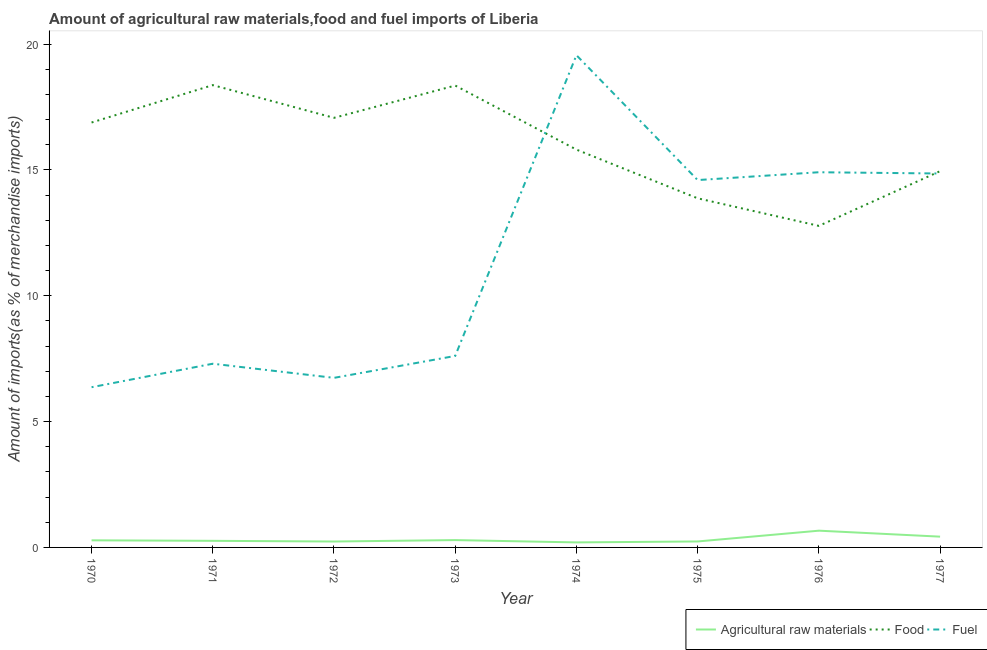Is the number of lines equal to the number of legend labels?
Provide a succinct answer. Yes. What is the percentage of raw materials imports in 1971?
Offer a very short reply. 0.26. Across all years, what is the maximum percentage of fuel imports?
Provide a succinct answer. 19.56. Across all years, what is the minimum percentage of food imports?
Provide a succinct answer. 12.78. In which year was the percentage of raw materials imports maximum?
Give a very brief answer. 1976. What is the total percentage of fuel imports in the graph?
Your answer should be very brief. 91.93. What is the difference between the percentage of raw materials imports in 1974 and that in 1976?
Offer a very short reply. -0.47. What is the difference between the percentage of food imports in 1975 and the percentage of raw materials imports in 1970?
Ensure brevity in your answer.  13.59. What is the average percentage of fuel imports per year?
Give a very brief answer. 11.49. In the year 1974, what is the difference between the percentage of fuel imports and percentage of food imports?
Give a very brief answer. 3.75. In how many years, is the percentage of raw materials imports greater than 4 %?
Keep it short and to the point. 0. What is the ratio of the percentage of food imports in 1970 to that in 1977?
Offer a terse response. 1.13. What is the difference between the highest and the second highest percentage of food imports?
Provide a short and direct response. 0.02. What is the difference between the highest and the lowest percentage of food imports?
Keep it short and to the point. 5.59. Is the sum of the percentage of fuel imports in 1974 and 1975 greater than the maximum percentage of raw materials imports across all years?
Your answer should be very brief. Yes. Is it the case that in every year, the sum of the percentage of raw materials imports and percentage of food imports is greater than the percentage of fuel imports?
Provide a short and direct response. No. Is the percentage of fuel imports strictly less than the percentage of raw materials imports over the years?
Your response must be concise. No. How many years are there in the graph?
Your response must be concise. 8. What is the difference between two consecutive major ticks on the Y-axis?
Keep it short and to the point. 5. Are the values on the major ticks of Y-axis written in scientific E-notation?
Offer a terse response. No. How are the legend labels stacked?
Offer a very short reply. Horizontal. What is the title of the graph?
Provide a succinct answer. Amount of agricultural raw materials,food and fuel imports of Liberia. Does "Negligence towards kids" appear as one of the legend labels in the graph?
Provide a short and direct response. No. What is the label or title of the Y-axis?
Make the answer very short. Amount of imports(as % of merchandise imports). What is the Amount of imports(as % of merchandise imports) of Agricultural raw materials in 1970?
Ensure brevity in your answer.  0.28. What is the Amount of imports(as % of merchandise imports) in Food in 1970?
Give a very brief answer. 16.88. What is the Amount of imports(as % of merchandise imports) of Fuel in 1970?
Offer a terse response. 6.37. What is the Amount of imports(as % of merchandise imports) of Agricultural raw materials in 1971?
Make the answer very short. 0.26. What is the Amount of imports(as % of merchandise imports) of Food in 1971?
Make the answer very short. 18.37. What is the Amount of imports(as % of merchandise imports) of Fuel in 1971?
Provide a short and direct response. 7.3. What is the Amount of imports(as % of merchandise imports) in Agricultural raw materials in 1972?
Give a very brief answer. 0.23. What is the Amount of imports(as % of merchandise imports) of Food in 1972?
Your answer should be very brief. 17.07. What is the Amount of imports(as % of merchandise imports) of Fuel in 1972?
Offer a very short reply. 6.74. What is the Amount of imports(as % of merchandise imports) in Agricultural raw materials in 1973?
Offer a very short reply. 0.29. What is the Amount of imports(as % of merchandise imports) in Food in 1973?
Give a very brief answer. 18.35. What is the Amount of imports(as % of merchandise imports) in Fuel in 1973?
Offer a very short reply. 7.61. What is the Amount of imports(as % of merchandise imports) in Agricultural raw materials in 1974?
Your response must be concise. 0.2. What is the Amount of imports(as % of merchandise imports) of Food in 1974?
Provide a succinct answer. 15.81. What is the Amount of imports(as % of merchandise imports) of Fuel in 1974?
Offer a very short reply. 19.56. What is the Amount of imports(as % of merchandise imports) of Agricultural raw materials in 1975?
Offer a terse response. 0.24. What is the Amount of imports(as % of merchandise imports) of Food in 1975?
Offer a very short reply. 13.87. What is the Amount of imports(as % of merchandise imports) in Fuel in 1975?
Your answer should be compact. 14.6. What is the Amount of imports(as % of merchandise imports) of Agricultural raw materials in 1976?
Ensure brevity in your answer.  0.67. What is the Amount of imports(as % of merchandise imports) in Food in 1976?
Ensure brevity in your answer.  12.78. What is the Amount of imports(as % of merchandise imports) in Fuel in 1976?
Your response must be concise. 14.91. What is the Amount of imports(as % of merchandise imports) in Agricultural raw materials in 1977?
Give a very brief answer. 0.43. What is the Amount of imports(as % of merchandise imports) of Food in 1977?
Your response must be concise. 14.95. What is the Amount of imports(as % of merchandise imports) of Fuel in 1977?
Give a very brief answer. 14.86. Across all years, what is the maximum Amount of imports(as % of merchandise imports) of Agricultural raw materials?
Offer a very short reply. 0.67. Across all years, what is the maximum Amount of imports(as % of merchandise imports) in Food?
Your answer should be very brief. 18.37. Across all years, what is the maximum Amount of imports(as % of merchandise imports) in Fuel?
Offer a terse response. 19.56. Across all years, what is the minimum Amount of imports(as % of merchandise imports) of Agricultural raw materials?
Ensure brevity in your answer.  0.2. Across all years, what is the minimum Amount of imports(as % of merchandise imports) in Food?
Offer a very short reply. 12.78. Across all years, what is the minimum Amount of imports(as % of merchandise imports) in Fuel?
Give a very brief answer. 6.37. What is the total Amount of imports(as % of merchandise imports) of Agricultural raw materials in the graph?
Offer a terse response. 2.6. What is the total Amount of imports(as % of merchandise imports) in Food in the graph?
Provide a short and direct response. 128.07. What is the total Amount of imports(as % of merchandise imports) in Fuel in the graph?
Provide a short and direct response. 91.93. What is the difference between the Amount of imports(as % of merchandise imports) in Agricultural raw materials in 1970 and that in 1971?
Your answer should be very brief. 0.02. What is the difference between the Amount of imports(as % of merchandise imports) in Food in 1970 and that in 1971?
Provide a short and direct response. -1.49. What is the difference between the Amount of imports(as % of merchandise imports) of Fuel in 1970 and that in 1971?
Make the answer very short. -0.93. What is the difference between the Amount of imports(as % of merchandise imports) in Agricultural raw materials in 1970 and that in 1972?
Provide a short and direct response. 0.05. What is the difference between the Amount of imports(as % of merchandise imports) in Food in 1970 and that in 1972?
Your response must be concise. -0.19. What is the difference between the Amount of imports(as % of merchandise imports) of Fuel in 1970 and that in 1972?
Your answer should be very brief. -0.37. What is the difference between the Amount of imports(as % of merchandise imports) of Agricultural raw materials in 1970 and that in 1973?
Your answer should be very brief. -0.01. What is the difference between the Amount of imports(as % of merchandise imports) of Food in 1970 and that in 1973?
Your answer should be very brief. -1.47. What is the difference between the Amount of imports(as % of merchandise imports) of Fuel in 1970 and that in 1973?
Keep it short and to the point. -1.24. What is the difference between the Amount of imports(as % of merchandise imports) of Agricultural raw materials in 1970 and that in 1974?
Provide a succinct answer. 0.08. What is the difference between the Amount of imports(as % of merchandise imports) of Food in 1970 and that in 1974?
Your answer should be compact. 1.08. What is the difference between the Amount of imports(as % of merchandise imports) in Fuel in 1970 and that in 1974?
Make the answer very short. -13.19. What is the difference between the Amount of imports(as % of merchandise imports) in Agricultural raw materials in 1970 and that in 1975?
Offer a very short reply. 0.04. What is the difference between the Amount of imports(as % of merchandise imports) of Food in 1970 and that in 1975?
Keep it short and to the point. 3.01. What is the difference between the Amount of imports(as % of merchandise imports) of Fuel in 1970 and that in 1975?
Keep it short and to the point. -8.23. What is the difference between the Amount of imports(as % of merchandise imports) in Agricultural raw materials in 1970 and that in 1976?
Offer a terse response. -0.38. What is the difference between the Amount of imports(as % of merchandise imports) of Food in 1970 and that in 1976?
Ensure brevity in your answer.  4.11. What is the difference between the Amount of imports(as % of merchandise imports) of Fuel in 1970 and that in 1976?
Provide a succinct answer. -8.54. What is the difference between the Amount of imports(as % of merchandise imports) in Agricultural raw materials in 1970 and that in 1977?
Your answer should be compact. -0.15. What is the difference between the Amount of imports(as % of merchandise imports) of Food in 1970 and that in 1977?
Give a very brief answer. 1.93. What is the difference between the Amount of imports(as % of merchandise imports) in Fuel in 1970 and that in 1977?
Offer a terse response. -8.49. What is the difference between the Amount of imports(as % of merchandise imports) of Agricultural raw materials in 1971 and that in 1972?
Your response must be concise. 0.03. What is the difference between the Amount of imports(as % of merchandise imports) in Food in 1971 and that in 1972?
Keep it short and to the point. 1.3. What is the difference between the Amount of imports(as % of merchandise imports) in Fuel in 1971 and that in 1972?
Make the answer very short. 0.56. What is the difference between the Amount of imports(as % of merchandise imports) of Agricultural raw materials in 1971 and that in 1973?
Provide a succinct answer. -0.03. What is the difference between the Amount of imports(as % of merchandise imports) of Food in 1971 and that in 1973?
Offer a terse response. 0.02. What is the difference between the Amount of imports(as % of merchandise imports) of Fuel in 1971 and that in 1973?
Offer a terse response. -0.31. What is the difference between the Amount of imports(as % of merchandise imports) in Agricultural raw materials in 1971 and that in 1974?
Provide a short and direct response. 0.06. What is the difference between the Amount of imports(as % of merchandise imports) in Food in 1971 and that in 1974?
Your answer should be compact. 2.56. What is the difference between the Amount of imports(as % of merchandise imports) of Fuel in 1971 and that in 1974?
Provide a succinct answer. -12.26. What is the difference between the Amount of imports(as % of merchandise imports) in Agricultural raw materials in 1971 and that in 1975?
Keep it short and to the point. 0.03. What is the difference between the Amount of imports(as % of merchandise imports) of Food in 1971 and that in 1975?
Your response must be concise. 4.5. What is the difference between the Amount of imports(as % of merchandise imports) in Fuel in 1971 and that in 1975?
Offer a terse response. -7.3. What is the difference between the Amount of imports(as % of merchandise imports) in Agricultural raw materials in 1971 and that in 1976?
Your response must be concise. -0.4. What is the difference between the Amount of imports(as % of merchandise imports) of Food in 1971 and that in 1976?
Offer a terse response. 5.59. What is the difference between the Amount of imports(as % of merchandise imports) in Fuel in 1971 and that in 1976?
Make the answer very short. -7.61. What is the difference between the Amount of imports(as % of merchandise imports) in Agricultural raw materials in 1971 and that in 1977?
Provide a succinct answer. -0.17. What is the difference between the Amount of imports(as % of merchandise imports) in Food in 1971 and that in 1977?
Provide a succinct answer. 3.42. What is the difference between the Amount of imports(as % of merchandise imports) of Fuel in 1971 and that in 1977?
Provide a succinct answer. -7.56. What is the difference between the Amount of imports(as % of merchandise imports) in Agricultural raw materials in 1972 and that in 1973?
Give a very brief answer. -0.06. What is the difference between the Amount of imports(as % of merchandise imports) in Food in 1972 and that in 1973?
Your answer should be compact. -1.28. What is the difference between the Amount of imports(as % of merchandise imports) of Fuel in 1972 and that in 1973?
Offer a very short reply. -0.87. What is the difference between the Amount of imports(as % of merchandise imports) in Agricultural raw materials in 1972 and that in 1974?
Make the answer very short. 0.04. What is the difference between the Amount of imports(as % of merchandise imports) of Food in 1972 and that in 1974?
Offer a terse response. 1.26. What is the difference between the Amount of imports(as % of merchandise imports) of Fuel in 1972 and that in 1974?
Provide a succinct answer. -12.82. What is the difference between the Amount of imports(as % of merchandise imports) in Agricultural raw materials in 1972 and that in 1975?
Ensure brevity in your answer.  -0. What is the difference between the Amount of imports(as % of merchandise imports) of Food in 1972 and that in 1975?
Your answer should be very brief. 3.2. What is the difference between the Amount of imports(as % of merchandise imports) of Fuel in 1972 and that in 1975?
Provide a short and direct response. -7.86. What is the difference between the Amount of imports(as % of merchandise imports) of Agricultural raw materials in 1972 and that in 1976?
Your answer should be compact. -0.43. What is the difference between the Amount of imports(as % of merchandise imports) of Food in 1972 and that in 1976?
Ensure brevity in your answer.  4.29. What is the difference between the Amount of imports(as % of merchandise imports) of Fuel in 1972 and that in 1976?
Give a very brief answer. -8.17. What is the difference between the Amount of imports(as % of merchandise imports) in Agricultural raw materials in 1972 and that in 1977?
Make the answer very short. -0.19. What is the difference between the Amount of imports(as % of merchandise imports) in Food in 1972 and that in 1977?
Your answer should be compact. 2.12. What is the difference between the Amount of imports(as % of merchandise imports) in Fuel in 1972 and that in 1977?
Provide a short and direct response. -8.12. What is the difference between the Amount of imports(as % of merchandise imports) in Agricultural raw materials in 1973 and that in 1974?
Make the answer very short. 0.09. What is the difference between the Amount of imports(as % of merchandise imports) in Food in 1973 and that in 1974?
Offer a very short reply. 2.55. What is the difference between the Amount of imports(as % of merchandise imports) of Fuel in 1973 and that in 1974?
Make the answer very short. -11.95. What is the difference between the Amount of imports(as % of merchandise imports) of Agricultural raw materials in 1973 and that in 1975?
Your response must be concise. 0.05. What is the difference between the Amount of imports(as % of merchandise imports) of Food in 1973 and that in 1975?
Give a very brief answer. 4.48. What is the difference between the Amount of imports(as % of merchandise imports) in Fuel in 1973 and that in 1975?
Ensure brevity in your answer.  -6.99. What is the difference between the Amount of imports(as % of merchandise imports) in Agricultural raw materials in 1973 and that in 1976?
Make the answer very short. -0.37. What is the difference between the Amount of imports(as % of merchandise imports) of Food in 1973 and that in 1976?
Ensure brevity in your answer.  5.58. What is the difference between the Amount of imports(as % of merchandise imports) of Fuel in 1973 and that in 1976?
Ensure brevity in your answer.  -7.3. What is the difference between the Amount of imports(as % of merchandise imports) of Agricultural raw materials in 1973 and that in 1977?
Keep it short and to the point. -0.14. What is the difference between the Amount of imports(as % of merchandise imports) of Food in 1973 and that in 1977?
Ensure brevity in your answer.  3.4. What is the difference between the Amount of imports(as % of merchandise imports) of Fuel in 1973 and that in 1977?
Keep it short and to the point. -7.25. What is the difference between the Amount of imports(as % of merchandise imports) of Agricultural raw materials in 1974 and that in 1975?
Your answer should be compact. -0.04. What is the difference between the Amount of imports(as % of merchandise imports) of Food in 1974 and that in 1975?
Offer a very short reply. 1.93. What is the difference between the Amount of imports(as % of merchandise imports) in Fuel in 1974 and that in 1975?
Offer a very short reply. 4.96. What is the difference between the Amount of imports(as % of merchandise imports) of Agricultural raw materials in 1974 and that in 1976?
Make the answer very short. -0.47. What is the difference between the Amount of imports(as % of merchandise imports) in Food in 1974 and that in 1976?
Give a very brief answer. 3.03. What is the difference between the Amount of imports(as % of merchandise imports) in Fuel in 1974 and that in 1976?
Ensure brevity in your answer.  4.65. What is the difference between the Amount of imports(as % of merchandise imports) in Agricultural raw materials in 1974 and that in 1977?
Your answer should be very brief. -0.23. What is the difference between the Amount of imports(as % of merchandise imports) of Food in 1974 and that in 1977?
Keep it short and to the point. 0.86. What is the difference between the Amount of imports(as % of merchandise imports) in Fuel in 1974 and that in 1977?
Give a very brief answer. 4.7. What is the difference between the Amount of imports(as % of merchandise imports) in Agricultural raw materials in 1975 and that in 1976?
Your answer should be compact. -0.43. What is the difference between the Amount of imports(as % of merchandise imports) in Food in 1975 and that in 1976?
Offer a very short reply. 1.1. What is the difference between the Amount of imports(as % of merchandise imports) in Fuel in 1975 and that in 1976?
Provide a short and direct response. -0.31. What is the difference between the Amount of imports(as % of merchandise imports) of Agricultural raw materials in 1975 and that in 1977?
Provide a short and direct response. -0.19. What is the difference between the Amount of imports(as % of merchandise imports) in Food in 1975 and that in 1977?
Give a very brief answer. -1.08. What is the difference between the Amount of imports(as % of merchandise imports) in Fuel in 1975 and that in 1977?
Your response must be concise. -0.26. What is the difference between the Amount of imports(as % of merchandise imports) in Agricultural raw materials in 1976 and that in 1977?
Give a very brief answer. 0.24. What is the difference between the Amount of imports(as % of merchandise imports) in Food in 1976 and that in 1977?
Offer a terse response. -2.17. What is the difference between the Amount of imports(as % of merchandise imports) in Fuel in 1976 and that in 1977?
Give a very brief answer. 0.05. What is the difference between the Amount of imports(as % of merchandise imports) in Agricultural raw materials in 1970 and the Amount of imports(as % of merchandise imports) in Food in 1971?
Provide a succinct answer. -18.09. What is the difference between the Amount of imports(as % of merchandise imports) of Agricultural raw materials in 1970 and the Amount of imports(as % of merchandise imports) of Fuel in 1971?
Give a very brief answer. -7.02. What is the difference between the Amount of imports(as % of merchandise imports) of Food in 1970 and the Amount of imports(as % of merchandise imports) of Fuel in 1971?
Provide a succinct answer. 9.58. What is the difference between the Amount of imports(as % of merchandise imports) in Agricultural raw materials in 1970 and the Amount of imports(as % of merchandise imports) in Food in 1972?
Ensure brevity in your answer.  -16.79. What is the difference between the Amount of imports(as % of merchandise imports) of Agricultural raw materials in 1970 and the Amount of imports(as % of merchandise imports) of Fuel in 1972?
Your answer should be very brief. -6.46. What is the difference between the Amount of imports(as % of merchandise imports) of Food in 1970 and the Amount of imports(as % of merchandise imports) of Fuel in 1972?
Make the answer very short. 10.15. What is the difference between the Amount of imports(as % of merchandise imports) in Agricultural raw materials in 1970 and the Amount of imports(as % of merchandise imports) in Food in 1973?
Offer a terse response. -18.07. What is the difference between the Amount of imports(as % of merchandise imports) in Agricultural raw materials in 1970 and the Amount of imports(as % of merchandise imports) in Fuel in 1973?
Give a very brief answer. -7.33. What is the difference between the Amount of imports(as % of merchandise imports) in Food in 1970 and the Amount of imports(as % of merchandise imports) in Fuel in 1973?
Offer a terse response. 9.27. What is the difference between the Amount of imports(as % of merchandise imports) in Agricultural raw materials in 1970 and the Amount of imports(as % of merchandise imports) in Food in 1974?
Give a very brief answer. -15.52. What is the difference between the Amount of imports(as % of merchandise imports) in Agricultural raw materials in 1970 and the Amount of imports(as % of merchandise imports) in Fuel in 1974?
Your answer should be very brief. -19.28. What is the difference between the Amount of imports(as % of merchandise imports) of Food in 1970 and the Amount of imports(as % of merchandise imports) of Fuel in 1974?
Ensure brevity in your answer.  -2.67. What is the difference between the Amount of imports(as % of merchandise imports) of Agricultural raw materials in 1970 and the Amount of imports(as % of merchandise imports) of Food in 1975?
Provide a short and direct response. -13.59. What is the difference between the Amount of imports(as % of merchandise imports) of Agricultural raw materials in 1970 and the Amount of imports(as % of merchandise imports) of Fuel in 1975?
Ensure brevity in your answer.  -14.31. What is the difference between the Amount of imports(as % of merchandise imports) of Food in 1970 and the Amount of imports(as % of merchandise imports) of Fuel in 1975?
Offer a very short reply. 2.29. What is the difference between the Amount of imports(as % of merchandise imports) of Agricultural raw materials in 1970 and the Amount of imports(as % of merchandise imports) of Food in 1976?
Keep it short and to the point. -12.49. What is the difference between the Amount of imports(as % of merchandise imports) in Agricultural raw materials in 1970 and the Amount of imports(as % of merchandise imports) in Fuel in 1976?
Make the answer very short. -14.62. What is the difference between the Amount of imports(as % of merchandise imports) in Food in 1970 and the Amount of imports(as % of merchandise imports) in Fuel in 1976?
Provide a short and direct response. 1.98. What is the difference between the Amount of imports(as % of merchandise imports) of Agricultural raw materials in 1970 and the Amount of imports(as % of merchandise imports) of Food in 1977?
Ensure brevity in your answer.  -14.67. What is the difference between the Amount of imports(as % of merchandise imports) of Agricultural raw materials in 1970 and the Amount of imports(as % of merchandise imports) of Fuel in 1977?
Give a very brief answer. -14.57. What is the difference between the Amount of imports(as % of merchandise imports) in Food in 1970 and the Amount of imports(as % of merchandise imports) in Fuel in 1977?
Your response must be concise. 2.03. What is the difference between the Amount of imports(as % of merchandise imports) in Agricultural raw materials in 1971 and the Amount of imports(as % of merchandise imports) in Food in 1972?
Make the answer very short. -16.81. What is the difference between the Amount of imports(as % of merchandise imports) in Agricultural raw materials in 1971 and the Amount of imports(as % of merchandise imports) in Fuel in 1972?
Ensure brevity in your answer.  -6.48. What is the difference between the Amount of imports(as % of merchandise imports) in Food in 1971 and the Amount of imports(as % of merchandise imports) in Fuel in 1972?
Keep it short and to the point. 11.63. What is the difference between the Amount of imports(as % of merchandise imports) in Agricultural raw materials in 1971 and the Amount of imports(as % of merchandise imports) in Food in 1973?
Your answer should be very brief. -18.09. What is the difference between the Amount of imports(as % of merchandise imports) of Agricultural raw materials in 1971 and the Amount of imports(as % of merchandise imports) of Fuel in 1973?
Ensure brevity in your answer.  -7.35. What is the difference between the Amount of imports(as % of merchandise imports) of Food in 1971 and the Amount of imports(as % of merchandise imports) of Fuel in 1973?
Your response must be concise. 10.76. What is the difference between the Amount of imports(as % of merchandise imports) in Agricultural raw materials in 1971 and the Amount of imports(as % of merchandise imports) in Food in 1974?
Your answer should be very brief. -15.54. What is the difference between the Amount of imports(as % of merchandise imports) in Agricultural raw materials in 1971 and the Amount of imports(as % of merchandise imports) in Fuel in 1974?
Make the answer very short. -19.3. What is the difference between the Amount of imports(as % of merchandise imports) in Food in 1971 and the Amount of imports(as % of merchandise imports) in Fuel in 1974?
Your answer should be compact. -1.19. What is the difference between the Amount of imports(as % of merchandise imports) of Agricultural raw materials in 1971 and the Amount of imports(as % of merchandise imports) of Food in 1975?
Make the answer very short. -13.61. What is the difference between the Amount of imports(as % of merchandise imports) of Agricultural raw materials in 1971 and the Amount of imports(as % of merchandise imports) of Fuel in 1975?
Ensure brevity in your answer.  -14.33. What is the difference between the Amount of imports(as % of merchandise imports) in Food in 1971 and the Amount of imports(as % of merchandise imports) in Fuel in 1975?
Give a very brief answer. 3.77. What is the difference between the Amount of imports(as % of merchandise imports) in Agricultural raw materials in 1971 and the Amount of imports(as % of merchandise imports) in Food in 1976?
Offer a very short reply. -12.51. What is the difference between the Amount of imports(as % of merchandise imports) in Agricultural raw materials in 1971 and the Amount of imports(as % of merchandise imports) in Fuel in 1976?
Your answer should be very brief. -14.64. What is the difference between the Amount of imports(as % of merchandise imports) in Food in 1971 and the Amount of imports(as % of merchandise imports) in Fuel in 1976?
Keep it short and to the point. 3.46. What is the difference between the Amount of imports(as % of merchandise imports) in Agricultural raw materials in 1971 and the Amount of imports(as % of merchandise imports) in Food in 1977?
Give a very brief answer. -14.69. What is the difference between the Amount of imports(as % of merchandise imports) in Agricultural raw materials in 1971 and the Amount of imports(as % of merchandise imports) in Fuel in 1977?
Make the answer very short. -14.59. What is the difference between the Amount of imports(as % of merchandise imports) of Food in 1971 and the Amount of imports(as % of merchandise imports) of Fuel in 1977?
Provide a succinct answer. 3.51. What is the difference between the Amount of imports(as % of merchandise imports) in Agricultural raw materials in 1972 and the Amount of imports(as % of merchandise imports) in Food in 1973?
Provide a short and direct response. -18.12. What is the difference between the Amount of imports(as % of merchandise imports) of Agricultural raw materials in 1972 and the Amount of imports(as % of merchandise imports) of Fuel in 1973?
Your response must be concise. -7.37. What is the difference between the Amount of imports(as % of merchandise imports) of Food in 1972 and the Amount of imports(as % of merchandise imports) of Fuel in 1973?
Make the answer very short. 9.46. What is the difference between the Amount of imports(as % of merchandise imports) in Agricultural raw materials in 1972 and the Amount of imports(as % of merchandise imports) in Food in 1974?
Your answer should be very brief. -15.57. What is the difference between the Amount of imports(as % of merchandise imports) in Agricultural raw materials in 1972 and the Amount of imports(as % of merchandise imports) in Fuel in 1974?
Keep it short and to the point. -19.32. What is the difference between the Amount of imports(as % of merchandise imports) of Food in 1972 and the Amount of imports(as % of merchandise imports) of Fuel in 1974?
Provide a succinct answer. -2.49. What is the difference between the Amount of imports(as % of merchandise imports) of Agricultural raw materials in 1972 and the Amount of imports(as % of merchandise imports) of Food in 1975?
Your answer should be very brief. -13.64. What is the difference between the Amount of imports(as % of merchandise imports) in Agricultural raw materials in 1972 and the Amount of imports(as % of merchandise imports) in Fuel in 1975?
Your answer should be very brief. -14.36. What is the difference between the Amount of imports(as % of merchandise imports) of Food in 1972 and the Amount of imports(as % of merchandise imports) of Fuel in 1975?
Your answer should be compact. 2.47. What is the difference between the Amount of imports(as % of merchandise imports) in Agricultural raw materials in 1972 and the Amount of imports(as % of merchandise imports) in Food in 1976?
Provide a succinct answer. -12.54. What is the difference between the Amount of imports(as % of merchandise imports) of Agricultural raw materials in 1972 and the Amount of imports(as % of merchandise imports) of Fuel in 1976?
Provide a succinct answer. -14.67. What is the difference between the Amount of imports(as % of merchandise imports) in Food in 1972 and the Amount of imports(as % of merchandise imports) in Fuel in 1976?
Provide a short and direct response. 2.16. What is the difference between the Amount of imports(as % of merchandise imports) of Agricultural raw materials in 1972 and the Amount of imports(as % of merchandise imports) of Food in 1977?
Keep it short and to the point. -14.71. What is the difference between the Amount of imports(as % of merchandise imports) in Agricultural raw materials in 1972 and the Amount of imports(as % of merchandise imports) in Fuel in 1977?
Offer a very short reply. -14.62. What is the difference between the Amount of imports(as % of merchandise imports) of Food in 1972 and the Amount of imports(as % of merchandise imports) of Fuel in 1977?
Your answer should be very brief. 2.21. What is the difference between the Amount of imports(as % of merchandise imports) in Agricultural raw materials in 1973 and the Amount of imports(as % of merchandise imports) in Food in 1974?
Provide a succinct answer. -15.51. What is the difference between the Amount of imports(as % of merchandise imports) in Agricultural raw materials in 1973 and the Amount of imports(as % of merchandise imports) in Fuel in 1974?
Offer a terse response. -19.27. What is the difference between the Amount of imports(as % of merchandise imports) in Food in 1973 and the Amount of imports(as % of merchandise imports) in Fuel in 1974?
Your answer should be compact. -1.21. What is the difference between the Amount of imports(as % of merchandise imports) in Agricultural raw materials in 1973 and the Amount of imports(as % of merchandise imports) in Food in 1975?
Offer a terse response. -13.58. What is the difference between the Amount of imports(as % of merchandise imports) in Agricultural raw materials in 1973 and the Amount of imports(as % of merchandise imports) in Fuel in 1975?
Keep it short and to the point. -14.3. What is the difference between the Amount of imports(as % of merchandise imports) in Food in 1973 and the Amount of imports(as % of merchandise imports) in Fuel in 1975?
Make the answer very short. 3.76. What is the difference between the Amount of imports(as % of merchandise imports) in Agricultural raw materials in 1973 and the Amount of imports(as % of merchandise imports) in Food in 1976?
Provide a succinct answer. -12.48. What is the difference between the Amount of imports(as % of merchandise imports) in Agricultural raw materials in 1973 and the Amount of imports(as % of merchandise imports) in Fuel in 1976?
Provide a short and direct response. -14.62. What is the difference between the Amount of imports(as % of merchandise imports) of Food in 1973 and the Amount of imports(as % of merchandise imports) of Fuel in 1976?
Give a very brief answer. 3.44. What is the difference between the Amount of imports(as % of merchandise imports) in Agricultural raw materials in 1973 and the Amount of imports(as % of merchandise imports) in Food in 1977?
Your answer should be compact. -14.66. What is the difference between the Amount of imports(as % of merchandise imports) in Agricultural raw materials in 1973 and the Amount of imports(as % of merchandise imports) in Fuel in 1977?
Your answer should be very brief. -14.56. What is the difference between the Amount of imports(as % of merchandise imports) of Food in 1973 and the Amount of imports(as % of merchandise imports) of Fuel in 1977?
Your response must be concise. 3.5. What is the difference between the Amount of imports(as % of merchandise imports) of Agricultural raw materials in 1974 and the Amount of imports(as % of merchandise imports) of Food in 1975?
Make the answer very short. -13.67. What is the difference between the Amount of imports(as % of merchandise imports) in Agricultural raw materials in 1974 and the Amount of imports(as % of merchandise imports) in Fuel in 1975?
Your answer should be very brief. -14.4. What is the difference between the Amount of imports(as % of merchandise imports) in Food in 1974 and the Amount of imports(as % of merchandise imports) in Fuel in 1975?
Offer a terse response. 1.21. What is the difference between the Amount of imports(as % of merchandise imports) in Agricultural raw materials in 1974 and the Amount of imports(as % of merchandise imports) in Food in 1976?
Ensure brevity in your answer.  -12.58. What is the difference between the Amount of imports(as % of merchandise imports) in Agricultural raw materials in 1974 and the Amount of imports(as % of merchandise imports) in Fuel in 1976?
Provide a short and direct response. -14.71. What is the difference between the Amount of imports(as % of merchandise imports) of Food in 1974 and the Amount of imports(as % of merchandise imports) of Fuel in 1976?
Give a very brief answer. 0.9. What is the difference between the Amount of imports(as % of merchandise imports) in Agricultural raw materials in 1974 and the Amount of imports(as % of merchandise imports) in Food in 1977?
Your response must be concise. -14.75. What is the difference between the Amount of imports(as % of merchandise imports) in Agricultural raw materials in 1974 and the Amount of imports(as % of merchandise imports) in Fuel in 1977?
Your answer should be compact. -14.66. What is the difference between the Amount of imports(as % of merchandise imports) of Food in 1974 and the Amount of imports(as % of merchandise imports) of Fuel in 1977?
Ensure brevity in your answer.  0.95. What is the difference between the Amount of imports(as % of merchandise imports) in Agricultural raw materials in 1975 and the Amount of imports(as % of merchandise imports) in Food in 1976?
Your response must be concise. -12.54. What is the difference between the Amount of imports(as % of merchandise imports) in Agricultural raw materials in 1975 and the Amount of imports(as % of merchandise imports) in Fuel in 1976?
Provide a succinct answer. -14.67. What is the difference between the Amount of imports(as % of merchandise imports) of Food in 1975 and the Amount of imports(as % of merchandise imports) of Fuel in 1976?
Provide a succinct answer. -1.04. What is the difference between the Amount of imports(as % of merchandise imports) in Agricultural raw materials in 1975 and the Amount of imports(as % of merchandise imports) in Food in 1977?
Your answer should be compact. -14.71. What is the difference between the Amount of imports(as % of merchandise imports) in Agricultural raw materials in 1975 and the Amount of imports(as % of merchandise imports) in Fuel in 1977?
Provide a short and direct response. -14.62. What is the difference between the Amount of imports(as % of merchandise imports) in Food in 1975 and the Amount of imports(as % of merchandise imports) in Fuel in 1977?
Your answer should be very brief. -0.98. What is the difference between the Amount of imports(as % of merchandise imports) of Agricultural raw materials in 1976 and the Amount of imports(as % of merchandise imports) of Food in 1977?
Ensure brevity in your answer.  -14.28. What is the difference between the Amount of imports(as % of merchandise imports) of Agricultural raw materials in 1976 and the Amount of imports(as % of merchandise imports) of Fuel in 1977?
Provide a short and direct response. -14.19. What is the difference between the Amount of imports(as % of merchandise imports) of Food in 1976 and the Amount of imports(as % of merchandise imports) of Fuel in 1977?
Offer a very short reply. -2.08. What is the average Amount of imports(as % of merchandise imports) of Agricultural raw materials per year?
Offer a terse response. 0.33. What is the average Amount of imports(as % of merchandise imports) of Food per year?
Your answer should be very brief. 16.01. What is the average Amount of imports(as % of merchandise imports) of Fuel per year?
Ensure brevity in your answer.  11.49. In the year 1970, what is the difference between the Amount of imports(as % of merchandise imports) of Agricultural raw materials and Amount of imports(as % of merchandise imports) of Food?
Give a very brief answer. -16.6. In the year 1970, what is the difference between the Amount of imports(as % of merchandise imports) in Agricultural raw materials and Amount of imports(as % of merchandise imports) in Fuel?
Ensure brevity in your answer.  -6.08. In the year 1970, what is the difference between the Amount of imports(as % of merchandise imports) in Food and Amount of imports(as % of merchandise imports) in Fuel?
Your answer should be compact. 10.52. In the year 1971, what is the difference between the Amount of imports(as % of merchandise imports) in Agricultural raw materials and Amount of imports(as % of merchandise imports) in Food?
Ensure brevity in your answer.  -18.11. In the year 1971, what is the difference between the Amount of imports(as % of merchandise imports) of Agricultural raw materials and Amount of imports(as % of merchandise imports) of Fuel?
Offer a terse response. -7.04. In the year 1971, what is the difference between the Amount of imports(as % of merchandise imports) in Food and Amount of imports(as % of merchandise imports) in Fuel?
Give a very brief answer. 11.07. In the year 1972, what is the difference between the Amount of imports(as % of merchandise imports) of Agricultural raw materials and Amount of imports(as % of merchandise imports) of Food?
Give a very brief answer. -16.83. In the year 1972, what is the difference between the Amount of imports(as % of merchandise imports) of Agricultural raw materials and Amount of imports(as % of merchandise imports) of Fuel?
Offer a very short reply. -6.5. In the year 1972, what is the difference between the Amount of imports(as % of merchandise imports) in Food and Amount of imports(as % of merchandise imports) in Fuel?
Provide a short and direct response. 10.33. In the year 1973, what is the difference between the Amount of imports(as % of merchandise imports) in Agricultural raw materials and Amount of imports(as % of merchandise imports) in Food?
Offer a very short reply. -18.06. In the year 1973, what is the difference between the Amount of imports(as % of merchandise imports) in Agricultural raw materials and Amount of imports(as % of merchandise imports) in Fuel?
Offer a very short reply. -7.32. In the year 1973, what is the difference between the Amount of imports(as % of merchandise imports) of Food and Amount of imports(as % of merchandise imports) of Fuel?
Provide a succinct answer. 10.74. In the year 1974, what is the difference between the Amount of imports(as % of merchandise imports) of Agricultural raw materials and Amount of imports(as % of merchandise imports) of Food?
Ensure brevity in your answer.  -15.61. In the year 1974, what is the difference between the Amount of imports(as % of merchandise imports) in Agricultural raw materials and Amount of imports(as % of merchandise imports) in Fuel?
Ensure brevity in your answer.  -19.36. In the year 1974, what is the difference between the Amount of imports(as % of merchandise imports) of Food and Amount of imports(as % of merchandise imports) of Fuel?
Give a very brief answer. -3.75. In the year 1975, what is the difference between the Amount of imports(as % of merchandise imports) in Agricultural raw materials and Amount of imports(as % of merchandise imports) in Food?
Your answer should be compact. -13.63. In the year 1975, what is the difference between the Amount of imports(as % of merchandise imports) of Agricultural raw materials and Amount of imports(as % of merchandise imports) of Fuel?
Offer a very short reply. -14.36. In the year 1975, what is the difference between the Amount of imports(as % of merchandise imports) of Food and Amount of imports(as % of merchandise imports) of Fuel?
Give a very brief answer. -0.72. In the year 1976, what is the difference between the Amount of imports(as % of merchandise imports) in Agricultural raw materials and Amount of imports(as % of merchandise imports) in Food?
Give a very brief answer. -12.11. In the year 1976, what is the difference between the Amount of imports(as % of merchandise imports) of Agricultural raw materials and Amount of imports(as % of merchandise imports) of Fuel?
Ensure brevity in your answer.  -14.24. In the year 1976, what is the difference between the Amount of imports(as % of merchandise imports) in Food and Amount of imports(as % of merchandise imports) in Fuel?
Give a very brief answer. -2.13. In the year 1977, what is the difference between the Amount of imports(as % of merchandise imports) of Agricultural raw materials and Amount of imports(as % of merchandise imports) of Food?
Your response must be concise. -14.52. In the year 1977, what is the difference between the Amount of imports(as % of merchandise imports) in Agricultural raw materials and Amount of imports(as % of merchandise imports) in Fuel?
Ensure brevity in your answer.  -14.43. In the year 1977, what is the difference between the Amount of imports(as % of merchandise imports) of Food and Amount of imports(as % of merchandise imports) of Fuel?
Provide a succinct answer. 0.09. What is the ratio of the Amount of imports(as % of merchandise imports) in Agricultural raw materials in 1970 to that in 1971?
Offer a very short reply. 1.08. What is the ratio of the Amount of imports(as % of merchandise imports) in Food in 1970 to that in 1971?
Keep it short and to the point. 0.92. What is the ratio of the Amount of imports(as % of merchandise imports) in Fuel in 1970 to that in 1971?
Offer a terse response. 0.87. What is the ratio of the Amount of imports(as % of merchandise imports) of Agricultural raw materials in 1970 to that in 1972?
Provide a short and direct response. 1.2. What is the ratio of the Amount of imports(as % of merchandise imports) in Fuel in 1970 to that in 1972?
Ensure brevity in your answer.  0.94. What is the ratio of the Amount of imports(as % of merchandise imports) in Agricultural raw materials in 1970 to that in 1973?
Ensure brevity in your answer.  0.97. What is the ratio of the Amount of imports(as % of merchandise imports) in Food in 1970 to that in 1973?
Your response must be concise. 0.92. What is the ratio of the Amount of imports(as % of merchandise imports) of Fuel in 1970 to that in 1973?
Offer a terse response. 0.84. What is the ratio of the Amount of imports(as % of merchandise imports) in Agricultural raw materials in 1970 to that in 1974?
Offer a very short reply. 1.41. What is the ratio of the Amount of imports(as % of merchandise imports) in Food in 1970 to that in 1974?
Ensure brevity in your answer.  1.07. What is the ratio of the Amount of imports(as % of merchandise imports) of Fuel in 1970 to that in 1974?
Offer a terse response. 0.33. What is the ratio of the Amount of imports(as % of merchandise imports) of Agricultural raw materials in 1970 to that in 1975?
Your answer should be very brief. 1.19. What is the ratio of the Amount of imports(as % of merchandise imports) of Food in 1970 to that in 1975?
Your answer should be very brief. 1.22. What is the ratio of the Amount of imports(as % of merchandise imports) in Fuel in 1970 to that in 1975?
Provide a short and direct response. 0.44. What is the ratio of the Amount of imports(as % of merchandise imports) in Agricultural raw materials in 1970 to that in 1976?
Offer a terse response. 0.42. What is the ratio of the Amount of imports(as % of merchandise imports) in Food in 1970 to that in 1976?
Your answer should be very brief. 1.32. What is the ratio of the Amount of imports(as % of merchandise imports) in Fuel in 1970 to that in 1976?
Give a very brief answer. 0.43. What is the ratio of the Amount of imports(as % of merchandise imports) of Agricultural raw materials in 1970 to that in 1977?
Offer a very short reply. 0.66. What is the ratio of the Amount of imports(as % of merchandise imports) of Food in 1970 to that in 1977?
Give a very brief answer. 1.13. What is the ratio of the Amount of imports(as % of merchandise imports) in Fuel in 1970 to that in 1977?
Make the answer very short. 0.43. What is the ratio of the Amount of imports(as % of merchandise imports) of Agricultural raw materials in 1971 to that in 1972?
Offer a very short reply. 1.12. What is the ratio of the Amount of imports(as % of merchandise imports) of Food in 1971 to that in 1972?
Keep it short and to the point. 1.08. What is the ratio of the Amount of imports(as % of merchandise imports) in Agricultural raw materials in 1971 to that in 1973?
Your answer should be compact. 0.9. What is the ratio of the Amount of imports(as % of merchandise imports) in Fuel in 1971 to that in 1973?
Provide a short and direct response. 0.96. What is the ratio of the Amount of imports(as % of merchandise imports) of Agricultural raw materials in 1971 to that in 1974?
Your answer should be compact. 1.31. What is the ratio of the Amount of imports(as % of merchandise imports) of Food in 1971 to that in 1974?
Offer a terse response. 1.16. What is the ratio of the Amount of imports(as % of merchandise imports) in Fuel in 1971 to that in 1974?
Your answer should be very brief. 0.37. What is the ratio of the Amount of imports(as % of merchandise imports) in Agricultural raw materials in 1971 to that in 1975?
Your answer should be compact. 1.11. What is the ratio of the Amount of imports(as % of merchandise imports) in Food in 1971 to that in 1975?
Offer a terse response. 1.32. What is the ratio of the Amount of imports(as % of merchandise imports) in Fuel in 1971 to that in 1975?
Ensure brevity in your answer.  0.5. What is the ratio of the Amount of imports(as % of merchandise imports) in Agricultural raw materials in 1971 to that in 1976?
Give a very brief answer. 0.39. What is the ratio of the Amount of imports(as % of merchandise imports) of Food in 1971 to that in 1976?
Your response must be concise. 1.44. What is the ratio of the Amount of imports(as % of merchandise imports) of Fuel in 1971 to that in 1976?
Your answer should be very brief. 0.49. What is the ratio of the Amount of imports(as % of merchandise imports) in Agricultural raw materials in 1971 to that in 1977?
Keep it short and to the point. 0.61. What is the ratio of the Amount of imports(as % of merchandise imports) of Food in 1971 to that in 1977?
Offer a terse response. 1.23. What is the ratio of the Amount of imports(as % of merchandise imports) of Fuel in 1971 to that in 1977?
Ensure brevity in your answer.  0.49. What is the ratio of the Amount of imports(as % of merchandise imports) of Agricultural raw materials in 1972 to that in 1973?
Offer a very short reply. 0.81. What is the ratio of the Amount of imports(as % of merchandise imports) of Food in 1972 to that in 1973?
Offer a terse response. 0.93. What is the ratio of the Amount of imports(as % of merchandise imports) in Fuel in 1972 to that in 1973?
Your answer should be very brief. 0.89. What is the ratio of the Amount of imports(as % of merchandise imports) of Agricultural raw materials in 1972 to that in 1974?
Your answer should be very brief. 1.18. What is the ratio of the Amount of imports(as % of merchandise imports) in Food in 1972 to that in 1974?
Provide a short and direct response. 1.08. What is the ratio of the Amount of imports(as % of merchandise imports) in Fuel in 1972 to that in 1974?
Your response must be concise. 0.34. What is the ratio of the Amount of imports(as % of merchandise imports) in Agricultural raw materials in 1972 to that in 1975?
Offer a terse response. 0.99. What is the ratio of the Amount of imports(as % of merchandise imports) of Food in 1972 to that in 1975?
Your answer should be compact. 1.23. What is the ratio of the Amount of imports(as % of merchandise imports) in Fuel in 1972 to that in 1975?
Keep it short and to the point. 0.46. What is the ratio of the Amount of imports(as % of merchandise imports) of Agricultural raw materials in 1972 to that in 1976?
Provide a short and direct response. 0.35. What is the ratio of the Amount of imports(as % of merchandise imports) in Food in 1972 to that in 1976?
Provide a short and direct response. 1.34. What is the ratio of the Amount of imports(as % of merchandise imports) in Fuel in 1972 to that in 1976?
Your response must be concise. 0.45. What is the ratio of the Amount of imports(as % of merchandise imports) of Agricultural raw materials in 1972 to that in 1977?
Offer a terse response. 0.55. What is the ratio of the Amount of imports(as % of merchandise imports) of Food in 1972 to that in 1977?
Provide a short and direct response. 1.14. What is the ratio of the Amount of imports(as % of merchandise imports) of Fuel in 1972 to that in 1977?
Offer a very short reply. 0.45. What is the ratio of the Amount of imports(as % of merchandise imports) of Agricultural raw materials in 1973 to that in 1974?
Your response must be concise. 1.46. What is the ratio of the Amount of imports(as % of merchandise imports) of Food in 1973 to that in 1974?
Offer a very short reply. 1.16. What is the ratio of the Amount of imports(as % of merchandise imports) in Fuel in 1973 to that in 1974?
Offer a very short reply. 0.39. What is the ratio of the Amount of imports(as % of merchandise imports) of Agricultural raw materials in 1973 to that in 1975?
Offer a very short reply. 1.23. What is the ratio of the Amount of imports(as % of merchandise imports) of Food in 1973 to that in 1975?
Make the answer very short. 1.32. What is the ratio of the Amount of imports(as % of merchandise imports) of Fuel in 1973 to that in 1975?
Ensure brevity in your answer.  0.52. What is the ratio of the Amount of imports(as % of merchandise imports) in Agricultural raw materials in 1973 to that in 1976?
Your response must be concise. 0.44. What is the ratio of the Amount of imports(as % of merchandise imports) of Food in 1973 to that in 1976?
Provide a succinct answer. 1.44. What is the ratio of the Amount of imports(as % of merchandise imports) of Fuel in 1973 to that in 1976?
Give a very brief answer. 0.51. What is the ratio of the Amount of imports(as % of merchandise imports) of Agricultural raw materials in 1973 to that in 1977?
Provide a succinct answer. 0.68. What is the ratio of the Amount of imports(as % of merchandise imports) of Food in 1973 to that in 1977?
Ensure brevity in your answer.  1.23. What is the ratio of the Amount of imports(as % of merchandise imports) of Fuel in 1973 to that in 1977?
Ensure brevity in your answer.  0.51. What is the ratio of the Amount of imports(as % of merchandise imports) in Agricultural raw materials in 1974 to that in 1975?
Offer a very short reply. 0.84. What is the ratio of the Amount of imports(as % of merchandise imports) of Food in 1974 to that in 1975?
Ensure brevity in your answer.  1.14. What is the ratio of the Amount of imports(as % of merchandise imports) in Fuel in 1974 to that in 1975?
Offer a terse response. 1.34. What is the ratio of the Amount of imports(as % of merchandise imports) in Agricultural raw materials in 1974 to that in 1976?
Give a very brief answer. 0.3. What is the ratio of the Amount of imports(as % of merchandise imports) of Food in 1974 to that in 1976?
Give a very brief answer. 1.24. What is the ratio of the Amount of imports(as % of merchandise imports) in Fuel in 1974 to that in 1976?
Offer a very short reply. 1.31. What is the ratio of the Amount of imports(as % of merchandise imports) in Agricultural raw materials in 1974 to that in 1977?
Your answer should be compact. 0.47. What is the ratio of the Amount of imports(as % of merchandise imports) in Food in 1974 to that in 1977?
Provide a short and direct response. 1.06. What is the ratio of the Amount of imports(as % of merchandise imports) in Fuel in 1974 to that in 1977?
Your answer should be compact. 1.32. What is the ratio of the Amount of imports(as % of merchandise imports) in Agricultural raw materials in 1975 to that in 1976?
Make the answer very short. 0.36. What is the ratio of the Amount of imports(as % of merchandise imports) of Food in 1975 to that in 1976?
Keep it short and to the point. 1.09. What is the ratio of the Amount of imports(as % of merchandise imports) in Fuel in 1975 to that in 1976?
Your answer should be compact. 0.98. What is the ratio of the Amount of imports(as % of merchandise imports) of Agricultural raw materials in 1975 to that in 1977?
Provide a succinct answer. 0.55. What is the ratio of the Amount of imports(as % of merchandise imports) in Food in 1975 to that in 1977?
Make the answer very short. 0.93. What is the ratio of the Amount of imports(as % of merchandise imports) in Fuel in 1975 to that in 1977?
Keep it short and to the point. 0.98. What is the ratio of the Amount of imports(as % of merchandise imports) in Agricultural raw materials in 1976 to that in 1977?
Offer a terse response. 1.55. What is the ratio of the Amount of imports(as % of merchandise imports) in Food in 1976 to that in 1977?
Your answer should be very brief. 0.85. What is the ratio of the Amount of imports(as % of merchandise imports) of Fuel in 1976 to that in 1977?
Make the answer very short. 1. What is the difference between the highest and the second highest Amount of imports(as % of merchandise imports) in Agricultural raw materials?
Keep it short and to the point. 0.24. What is the difference between the highest and the second highest Amount of imports(as % of merchandise imports) of Food?
Provide a succinct answer. 0.02. What is the difference between the highest and the second highest Amount of imports(as % of merchandise imports) in Fuel?
Offer a terse response. 4.65. What is the difference between the highest and the lowest Amount of imports(as % of merchandise imports) of Agricultural raw materials?
Offer a very short reply. 0.47. What is the difference between the highest and the lowest Amount of imports(as % of merchandise imports) in Food?
Ensure brevity in your answer.  5.59. What is the difference between the highest and the lowest Amount of imports(as % of merchandise imports) in Fuel?
Offer a terse response. 13.19. 